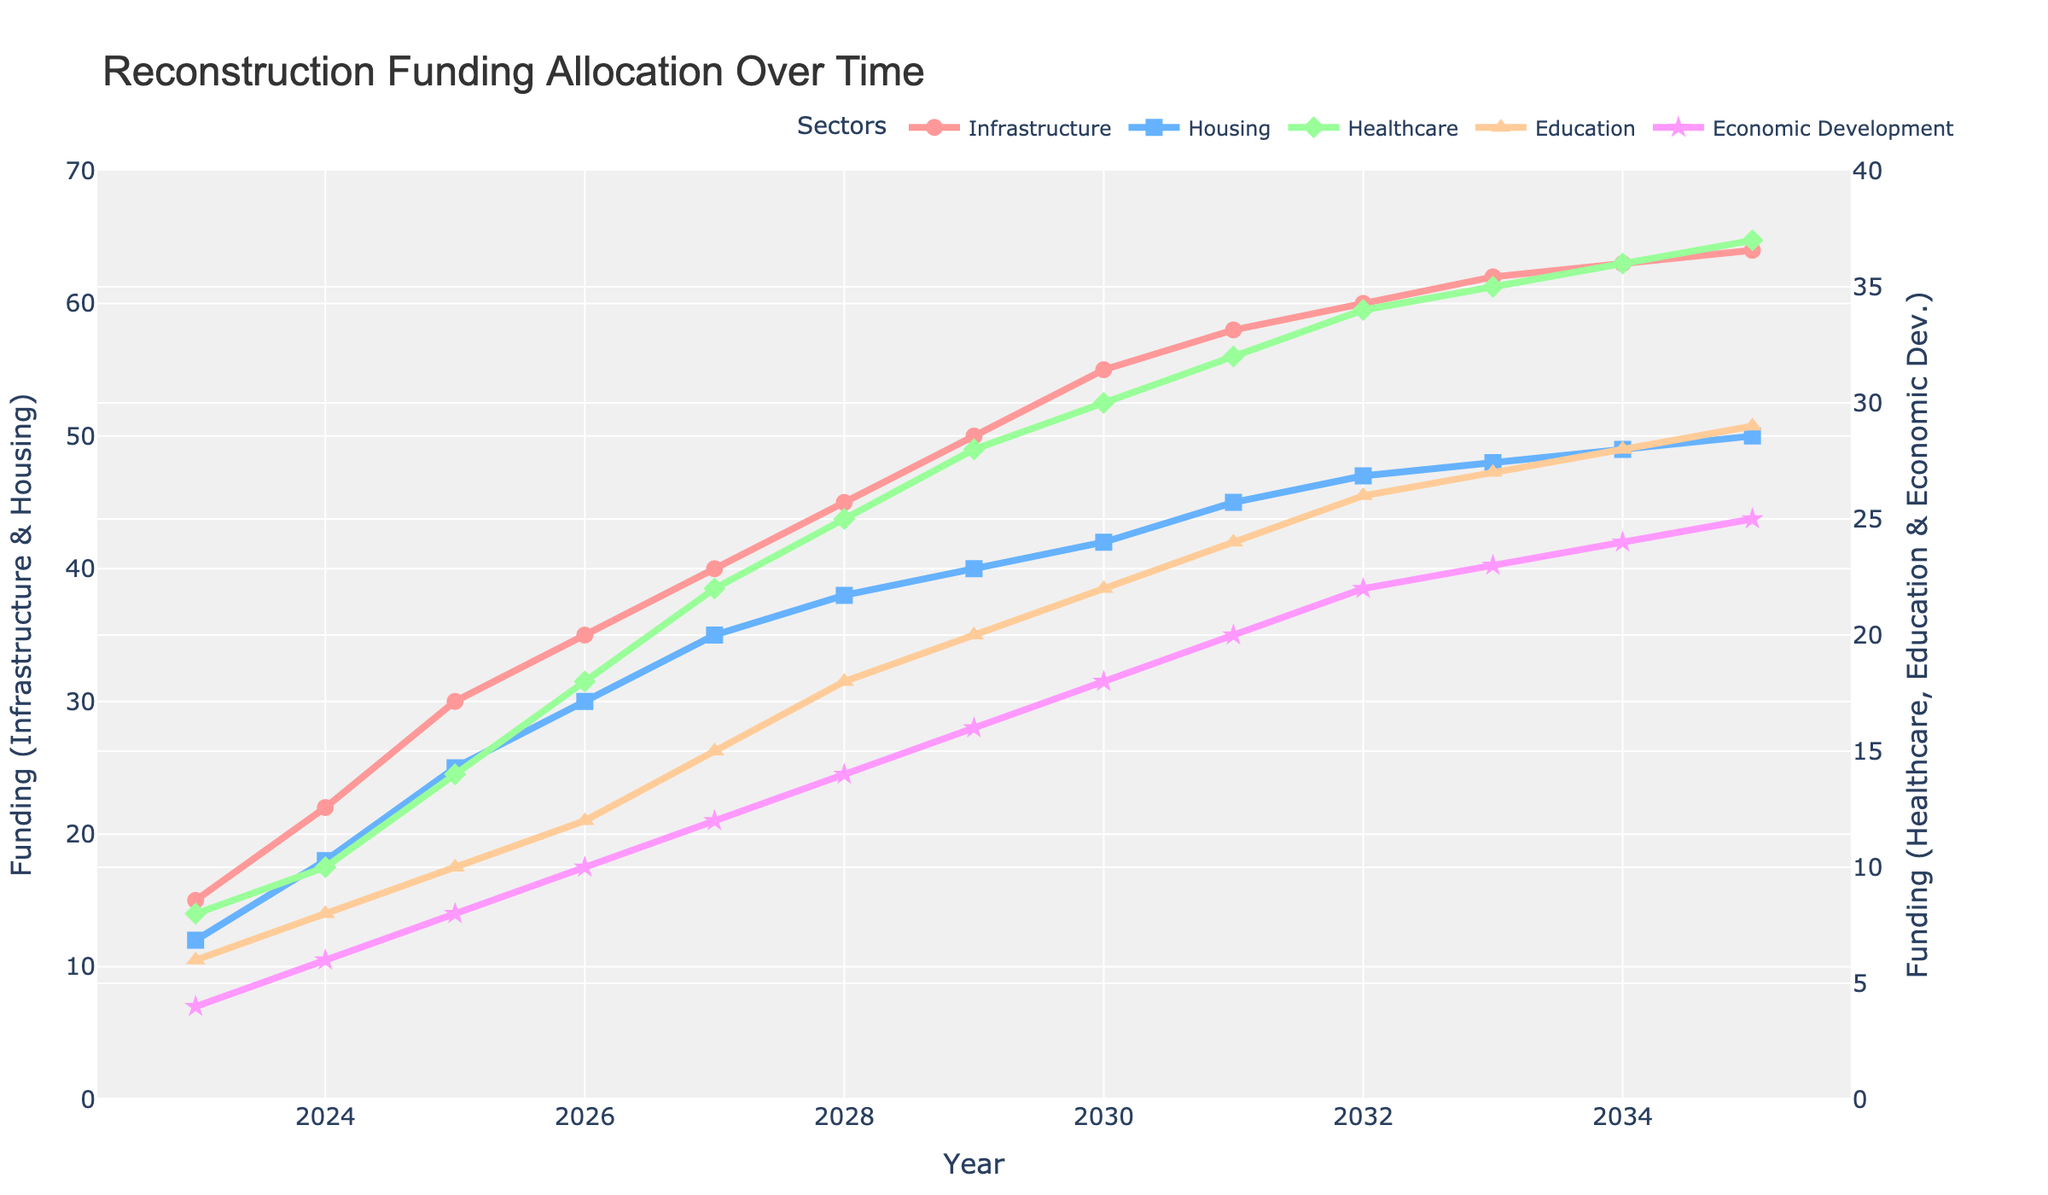what is the overall trend in infrastructure funding from 2023 to 2035? The line for infrastructure funding shows a steady increase from 2023 to 2035, starting at 15 in 2023 and reaching 64 in 2035. This indicates a consistent rise in infrastructure funding over the years.
Answer: Increasing trend Which sector received the most funding in 2029? The line chart shows that infrastructure, represented by the highest line in 2029, received the most funding at 50 units.
Answer: Infrastructure How much more funding did housing receive compared to healthcare in 2028? In 2028, housing received 38 units of funding and healthcare received 25 units. The difference is 38 - 25 = 13.
Answer: 13 units What is the average funding for economic development between 2023 and 2027? The funding amounts for economic development from 2023 to 2027 are 4, 6, 8, 10, and 12. Summing these values gives 4 + 6 + 8 + 10 + 12 = 40, and the average is 40 / 5 = 8.
Answer: 8 units Which sector had the most rapid growth in funding from 2023 to 2026? By comparing the slopes of the lines, infrastructure funding increased from 15 to 35 (20 units), which is the highest increase among sectors during this period.
Answer: Infrastructure By how much did education funding increase from 2023 to 2035? Education funding increased from 6 in 2023 to 29 in 2035. The increase can be calculated as 29 - 6 = 23.
Answer: 23 units In what year did healthcare funding surpass 20 units? The line for healthcare funding surpasses 20 units in the year 2026.
Answer: 2026 What is the relationship between the trend of economic development funding and education funding? Both lines for economic development and education funding show a similar upward trend from 2023 to 2035, with each increasing over the years in parallel.
Answer: Similar upward trend When did housing funding first exceed infrastructure funding? The funding for housing did not exceed infrastructure funding at any point from 2023 to 2035. Infrastructure always remained higher.
Answer: Never What is the average increase in infrastructure funding per year from 2023 to 2035? The increase in infrastructure funding from 15 to 64 over 12 years is (64 - 15) / (2035 - 2023) = 49 / 12 ≈ 4.08 units per year.
Answer: 4.08 units per year 